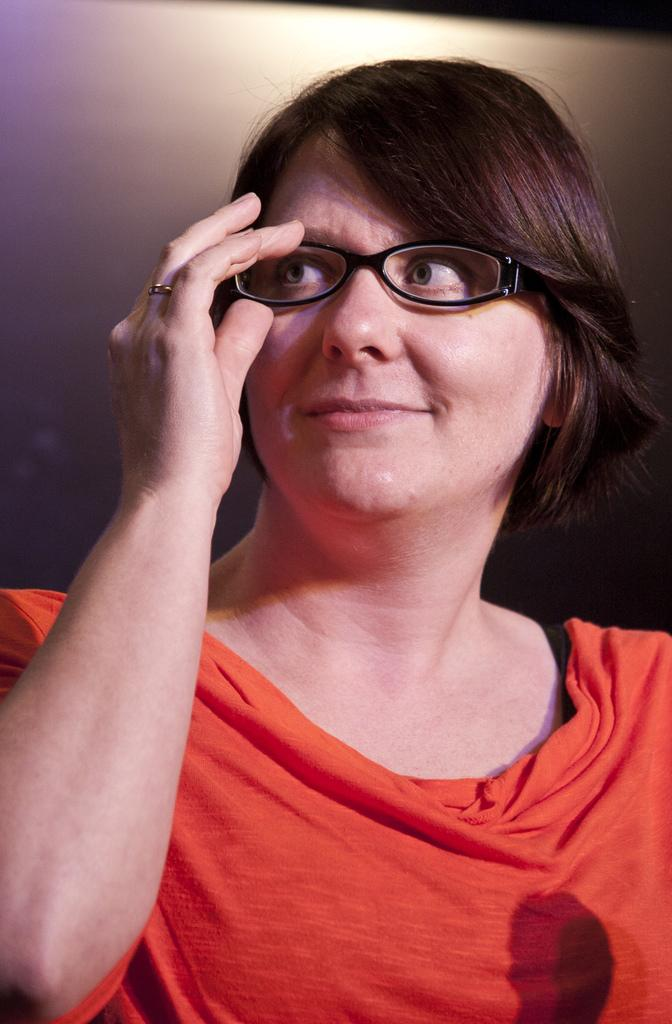What is the main subject of the image? There is a person in the image. What is the person holding in the image? The person is holding a spectacle. What is the color of the background in the image? The background in the image is white. How many friends can be seen in the image? There are no friends visible in the image; it only features a person holding a spectacle against a white background. What type of power source is used to light up the ocean in the image? There is no ocean or power source present in the image; it only features a person holding a spectacle against a white background. 